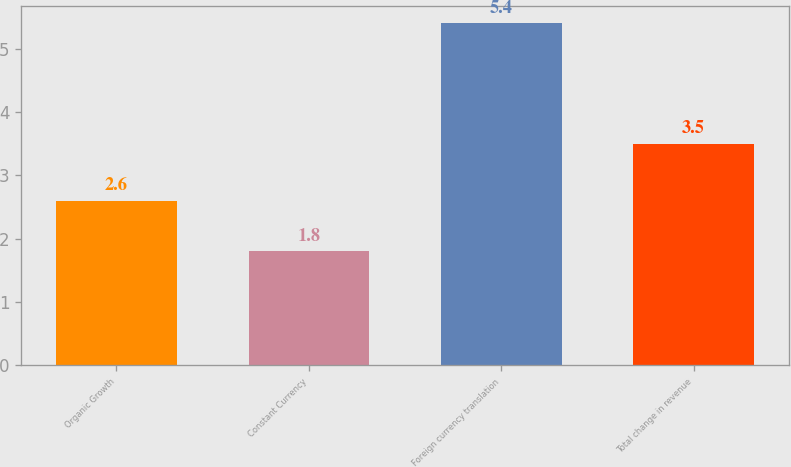Convert chart to OTSL. <chart><loc_0><loc_0><loc_500><loc_500><bar_chart><fcel>Organic Growth<fcel>Constant Currency<fcel>Foreign currency translation<fcel>Total change in revenue<nl><fcel>2.6<fcel>1.8<fcel>5.4<fcel>3.5<nl></chart> 